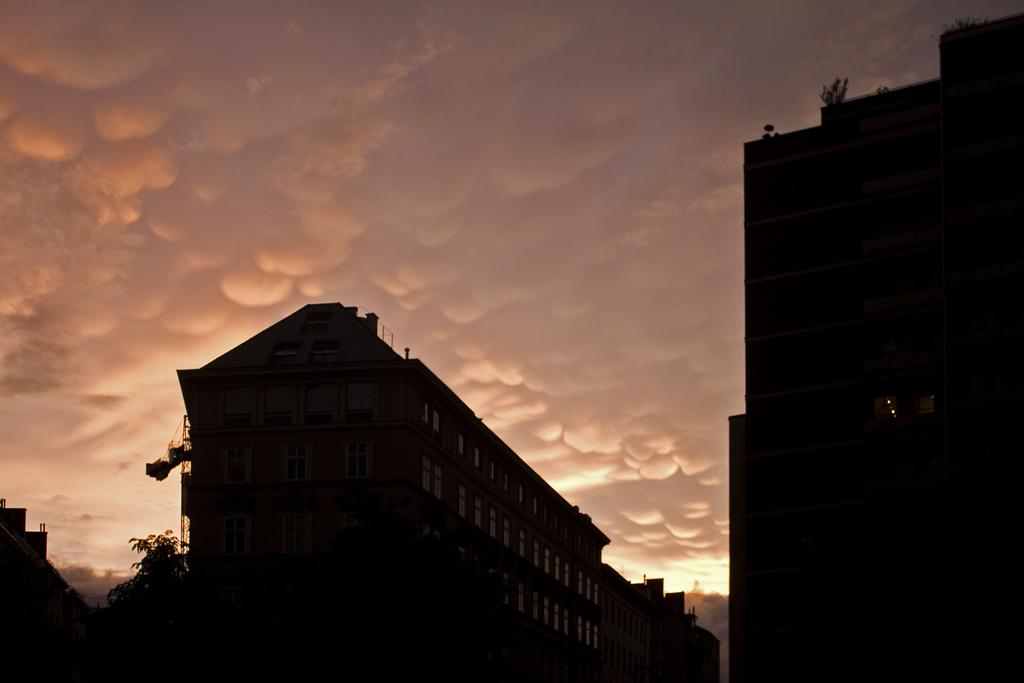What type of structures are visible in the image? There are buildings in the image. What feature do the buildings have? The buildings have windows. Where is the tree located in the image? The tree is on the left side of the image. What type of vegetation is present at the top of the buildings? Small plants are present at the top of the buildings. What can be seen in the sky at the top of the image? There are clouds in the sky at the top of the image. How many eyes can be seen on the chickens in the image? There are no chickens present in the image, so it is not possible to determine the number of eyes. 